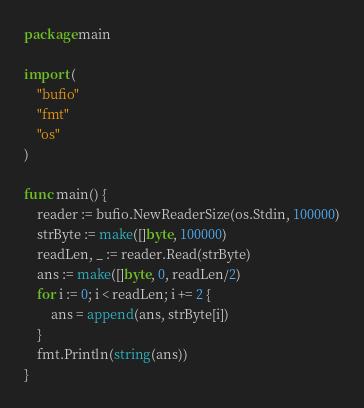<code> <loc_0><loc_0><loc_500><loc_500><_Go_>package main

import (
	"bufio"
	"fmt"
	"os"
)

func main() {
	reader := bufio.NewReaderSize(os.Stdin, 100000)
	strByte := make([]byte, 100000)
	readLen, _ := reader.Read(strByte)
	ans := make([]byte, 0, readLen/2)
	for i := 0; i < readLen; i += 2 {
		ans = append(ans, strByte[i])
	}
	fmt.Println(string(ans))
}</code> 